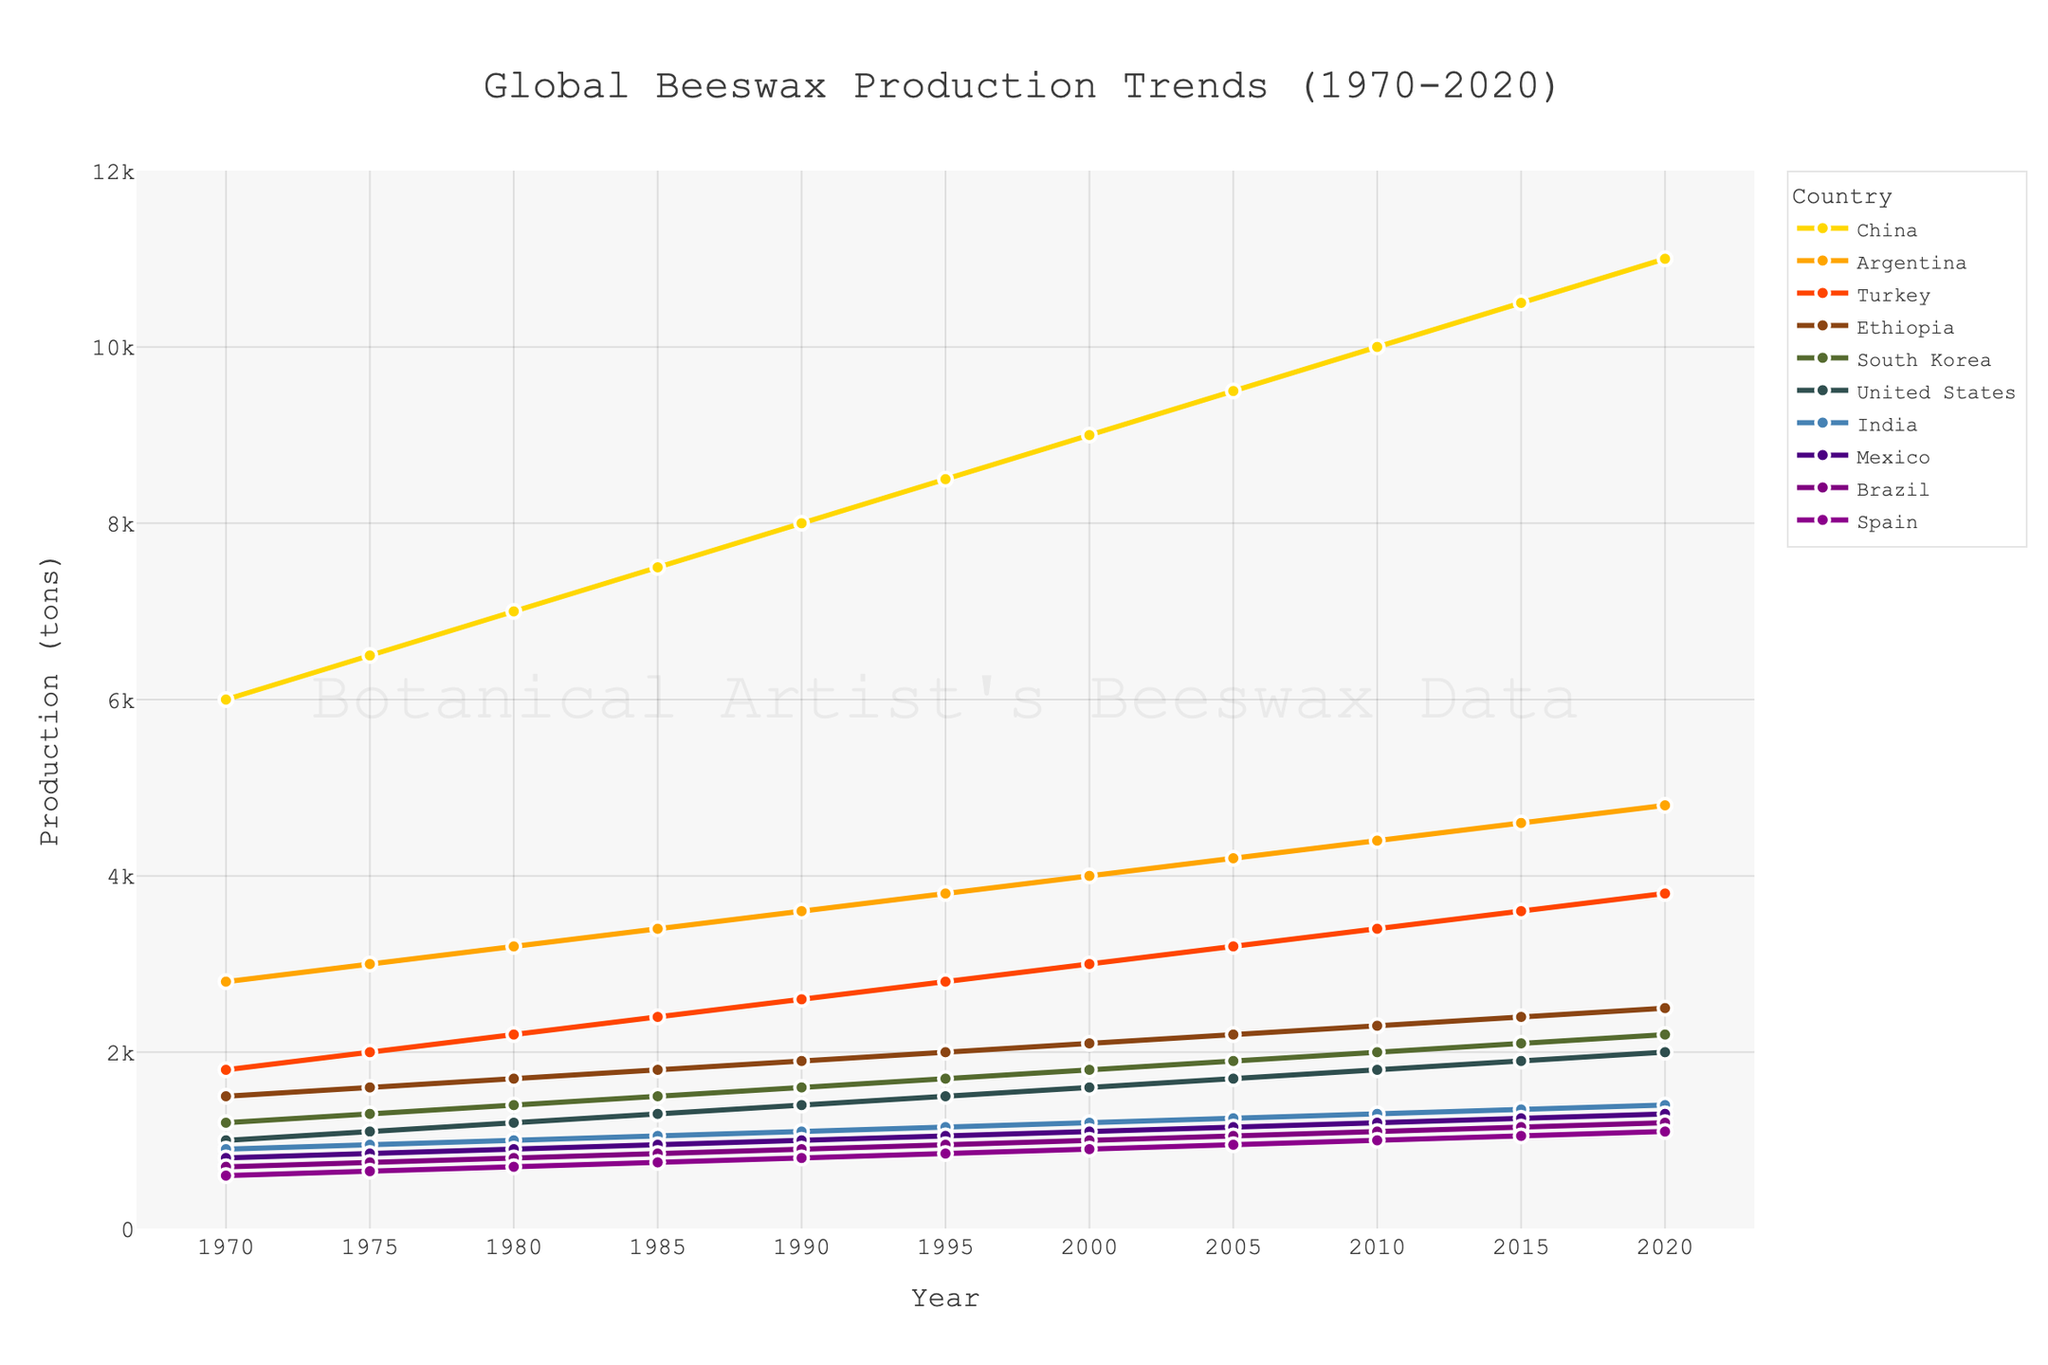what country had the highest beeswax production in 2020? By referring to the endpoints (2020) of all lines, the highest point is for China.
Answer: China how did the production trend of Argentina compare to that of Turkey between 1970 and 2020? Both Argentina and Turkey show an upward trend in beeswax production. However, Argentina's production consistently remains higher than Turkey's throughout the period.
Answer: Argentina's production was higher what is the average production of beeswax in the United States from 1970 to 2020? Sum the values of the United States from 1970 to 2020: (1000 + 1100 + 1200 + 1300 + 1400 + 1500 + 1600 + 1700 + 1800 + 1900 + 2000) = 16500. There are 11 years. So, 16500 / 11 = 1500
Answer: 1500 which country experienced the steepest increase in production between 1990 and 2000? By examining the slopes of the lines between 1990 and 2000, China shows the steepest increase, growing from 8000 to 9000 tons.
Answer: China how does the production of Brazil in 2000 compare to that of India in the same year? In 2000, Brazil's production was 1000 tons, whereas India's production was 1200 tons.
Answer: India's production was higher what is the difference in production between the highest and lowest producing countries in 2020? The highest production in 2020 is China with 11000 tons, and the lowest is Spain with 1100 tons. Difference = 11000 - 1100 = 9900
Answer: 9900 what has been the production trend of South Korea from 1970 to 2020? South Korea's production shows a consistent upward trend from 1200 in 1970 to 2200 in 2020.
Answer: Increasing which three countries had the closest production figures in 1970? In 1970, Turkey (1800), Ethiopia (1500), and South Korea (1200) had the closest production figures.
Answer: Turkey, Ethiopia, South Korea what is the total production of beeswax in China and India in 2020? The production in China in 2020 is 11000 tons and in India is 1400 tons. So, the total is 11000 + 1400 = 12400 tons.
Answer: 12400 how does the increase in production from 2000 to 2020 for Ethiopia compare to that for Mexico? Ethiopia's production increased from 2100 tons in 2000 to 2500 tons in 2020, an increase of 400 tons. Mexico's production increased from 1100 tons in 2000 to 1300 tons in 2020, an increase of 200 tons.
Answer: Ethiopia's increase was higher 